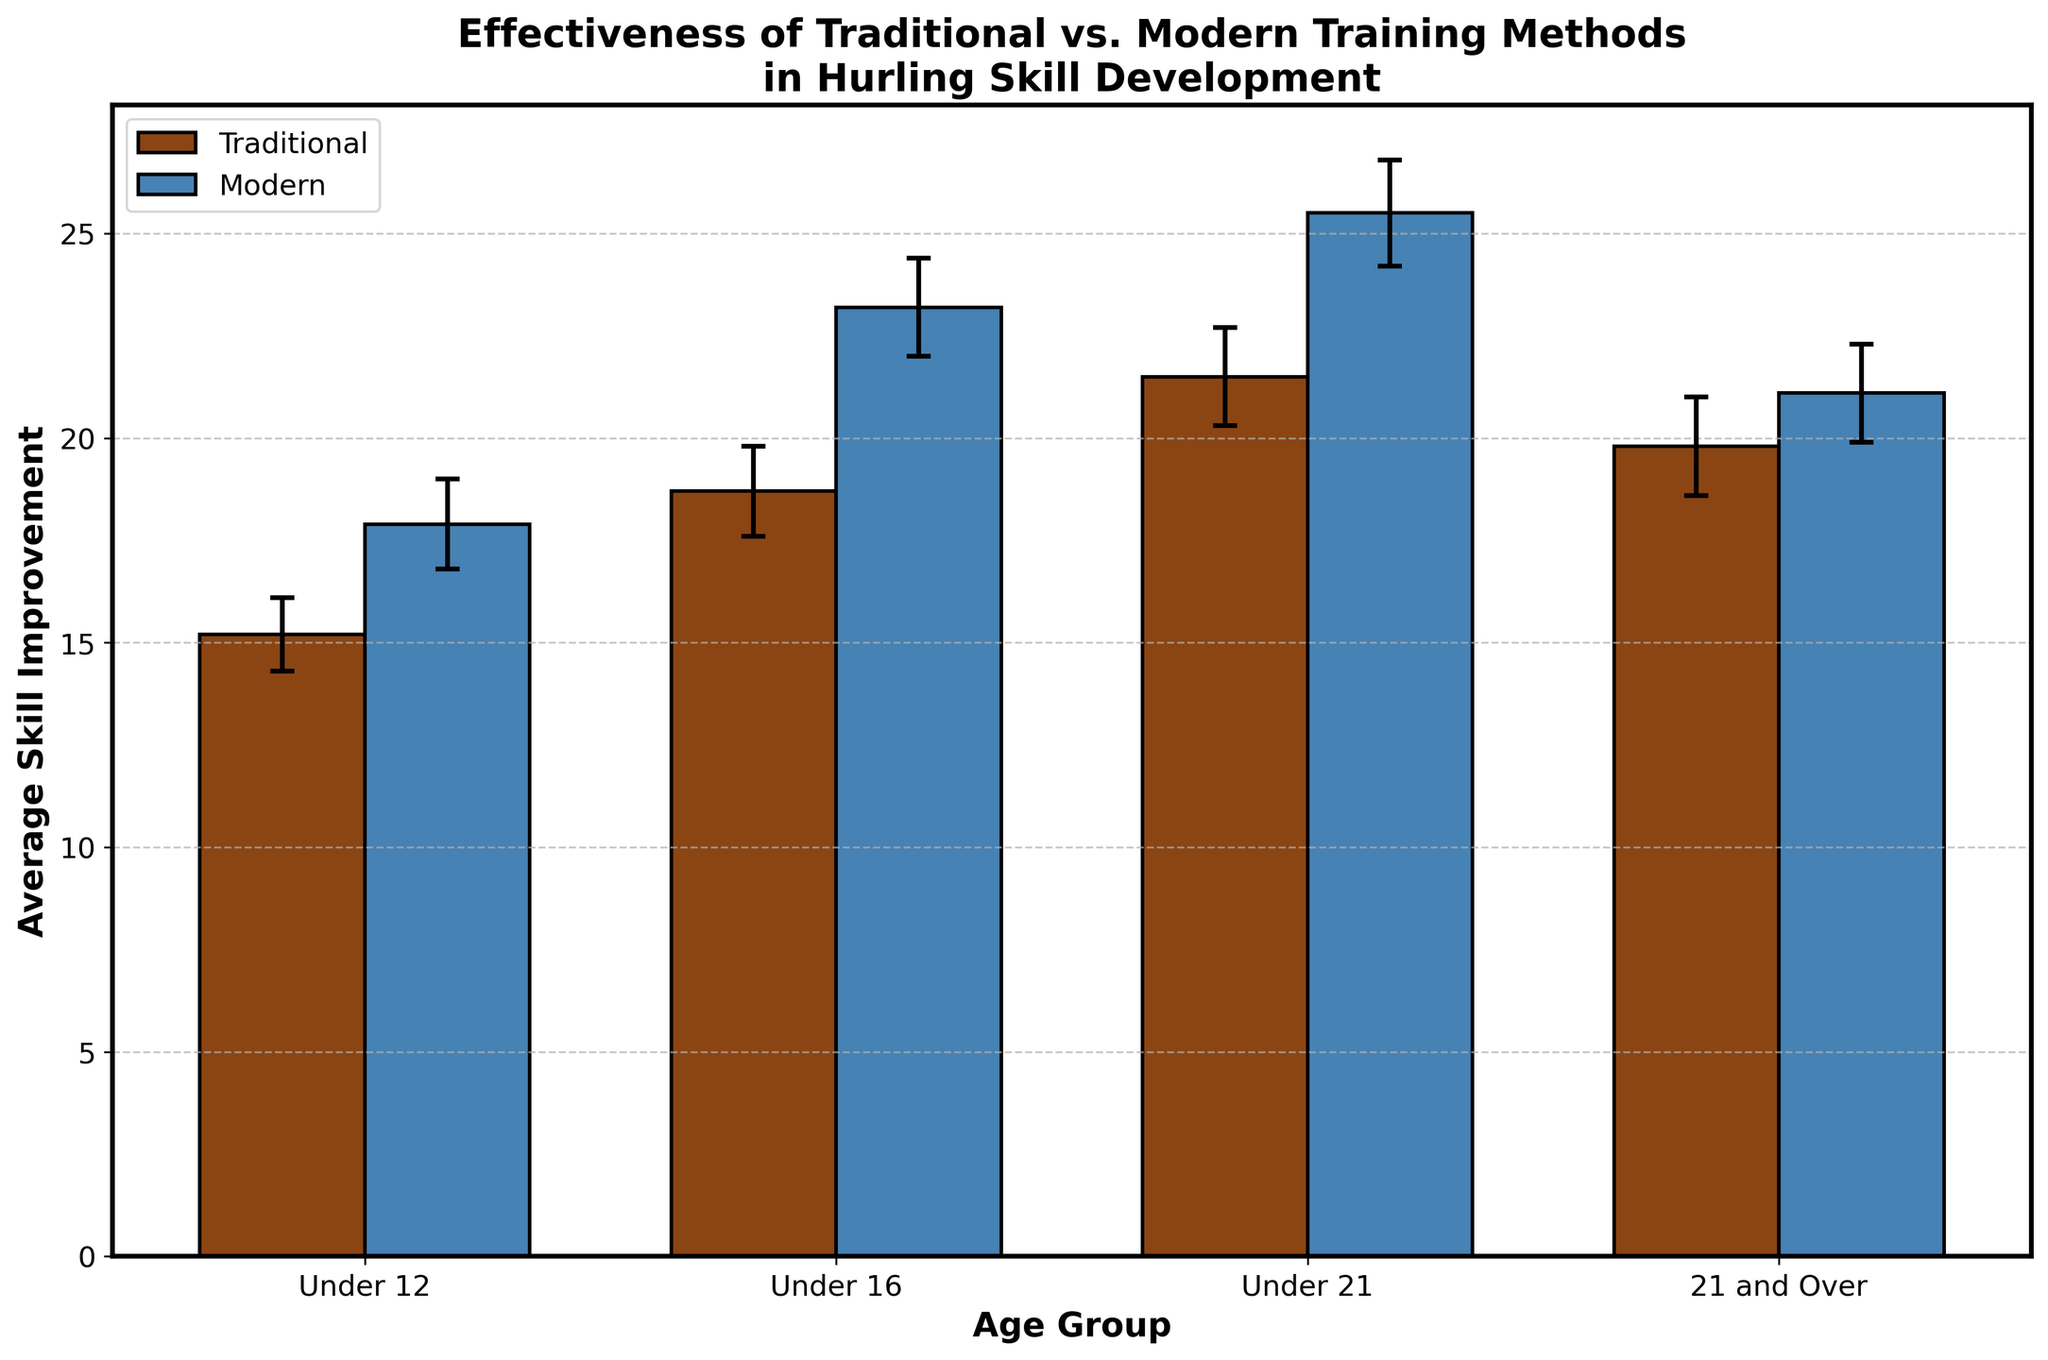What is the title of the figure? The title is usually located at the top of the figure and is often bolded to indicate its importance. Refer to the figure to read the title directly.
Answer: Effectiveness of Traditional vs. Modern Training Methods in Hurling Skill Development Which age group shows the highest average skill improvement for Modern training methods? Look at the bars labeled "Modern" and identify which age group has the tallest bar.
Answer: Under 21 What is the difference in average skill improvement between Traditional and Modern training methods for the Under 16 age group? Identify the height of the bars for both Traditional and Modern methods in the Under 16 category and calculate the difference. Traditional: 18.7, Modern: 23.2. The difference is 23.2 - 18.7.
Answer: 4.5 In which age group do Traditional training methods perform better than Modern training methods? Compare the height of the bars for all age groups and find the one where Traditional method's bar is taller than Modern's.
Answer: None What is the confidence interval range for the Under 21 group's skill improvement using Traditional methods? Locate the error bars for the Under 21 group under Traditional methods and read the lower and upper bounds of the confidence interval.
Answer: 20.3 to 22.7 How many age groups are represented in the plot? Count the number of distinct categories on the x-axis of the plot which represent different age groups.
Answer: 4 Which training method shows a smaller average skill improvement for the 21 and Over age group? Compare the heights of the bars for the "21 and Over" category and identify which one is shorter.
Answer: Traditional What is the total average skill improvement across all age groups for Modern training methods? Sum up the average skill improvement values for all age groups under Modern methods. 17.9 + 23.2 + 25.5 + 21.1
Answer: 87.7 Which training method has a wider confidence interval for the Under 12 age group? Compare the error bars' lengths for both Traditional and Modern methods in the Under 12 category. Traditional: 16.1 - 14.3 = 1.8, Modern: 19.0 - 16.8 = 2.2.
Answer: Modern 